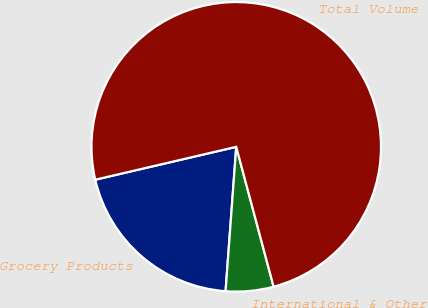<chart> <loc_0><loc_0><loc_500><loc_500><pie_chart><fcel>Grocery Products<fcel>International & Other<fcel>Total Volume<nl><fcel>20.18%<fcel>5.33%<fcel>74.48%<nl></chart> 